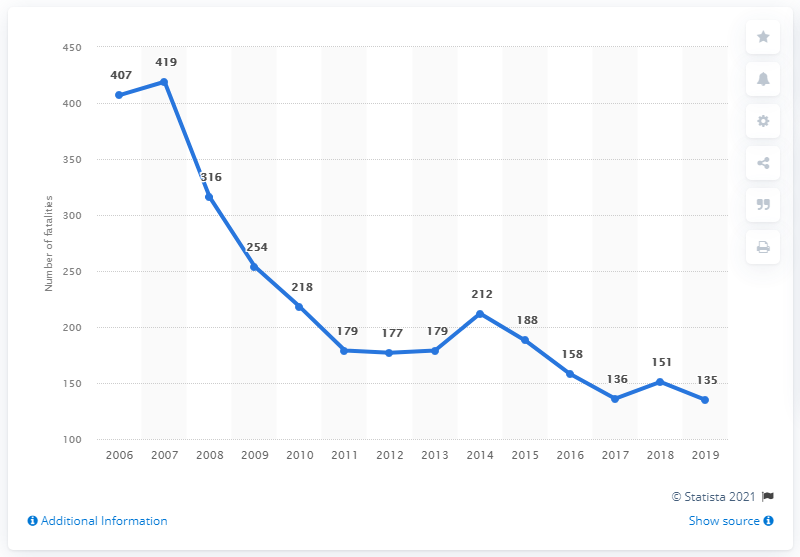Can you indicate the years when there was a noticeable increase in road fatalities based on the graph? According to the graph, there is a noticeable increase in road fatalities from 2011 to 2012 where the number rose from 177 to 212 fatalities. What could have caused the sudden increase in road fatalities during 2011 to 2012? The sudden increase in road fatalities from 2011 to 2012 could be attributed to several potential factors such as an increase in vehicle traffic, deteriorating road conditions, or possibly lesser enforcement of traffic regulations during that period. Detailed local data and research would be required to pinpoint exact causes. 